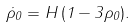Convert formula to latex. <formula><loc_0><loc_0><loc_500><loc_500>\dot { \rho } _ { 0 } = H \, ( 1 - 3 \rho _ { 0 } ) .</formula> 